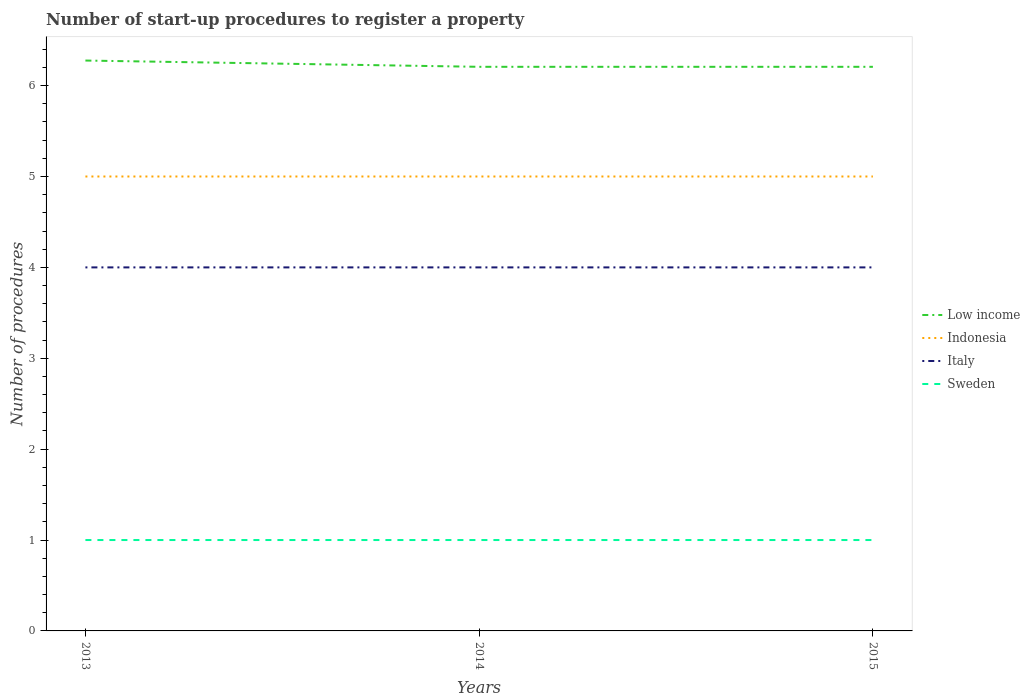How many different coloured lines are there?
Give a very brief answer. 4. Does the line corresponding to Italy intersect with the line corresponding to Indonesia?
Offer a terse response. No. Across all years, what is the maximum number of procedures required to register a property in Sweden?
Keep it short and to the point. 1. In which year was the number of procedures required to register a property in Low income maximum?
Offer a terse response. 2014. What is the total number of procedures required to register a property in Sweden in the graph?
Keep it short and to the point. 0. What is the difference between the highest and the second highest number of procedures required to register a property in Low income?
Make the answer very short. 0.07. What is the difference between the highest and the lowest number of procedures required to register a property in Indonesia?
Ensure brevity in your answer.  0. Is the number of procedures required to register a property in Sweden strictly greater than the number of procedures required to register a property in Indonesia over the years?
Your answer should be very brief. Yes. How many lines are there?
Provide a succinct answer. 4. How many years are there in the graph?
Your response must be concise. 3. Does the graph contain any zero values?
Give a very brief answer. No. Does the graph contain grids?
Offer a terse response. No. Where does the legend appear in the graph?
Your response must be concise. Center right. What is the title of the graph?
Give a very brief answer. Number of start-up procedures to register a property. What is the label or title of the X-axis?
Give a very brief answer. Years. What is the label or title of the Y-axis?
Ensure brevity in your answer.  Number of procedures. What is the Number of procedures of Low income in 2013?
Your response must be concise. 6.28. What is the Number of procedures in Indonesia in 2013?
Keep it short and to the point. 5. What is the Number of procedures in Sweden in 2013?
Provide a succinct answer. 1. What is the Number of procedures in Low income in 2014?
Make the answer very short. 6.21. What is the Number of procedures in Indonesia in 2014?
Keep it short and to the point. 5. What is the Number of procedures in Low income in 2015?
Your answer should be very brief. 6.21. What is the Number of procedures of Sweden in 2015?
Ensure brevity in your answer.  1. Across all years, what is the maximum Number of procedures in Low income?
Your answer should be very brief. 6.28. Across all years, what is the maximum Number of procedures of Indonesia?
Your answer should be very brief. 5. Across all years, what is the maximum Number of procedures in Italy?
Your response must be concise. 4. Across all years, what is the maximum Number of procedures in Sweden?
Provide a succinct answer. 1. Across all years, what is the minimum Number of procedures in Low income?
Your response must be concise. 6.21. What is the total Number of procedures in Low income in the graph?
Provide a short and direct response. 18.69. What is the total Number of procedures of Italy in the graph?
Keep it short and to the point. 12. What is the total Number of procedures in Sweden in the graph?
Your answer should be very brief. 3. What is the difference between the Number of procedures in Low income in 2013 and that in 2014?
Your answer should be very brief. 0.07. What is the difference between the Number of procedures in Italy in 2013 and that in 2014?
Offer a terse response. 0. What is the difference between the Number of procedures of Sweden in 2013 and that in 2014?
Provide a short and direct response. 0. What is the difference between the Number of procedures in Low income in 2013 and that in 2015?
Provide a short and direct response. 0.07. What is the difference between the Number of procedures in Indonesia in 2013 and that in 2015?
Offer a terse response. 0. What is the difference between the Number of procedures of Sweden in 2014 and that in 2015?
Provide a succinct answer. 0. What is the difference between the Number of procedures in Low income in 2013 and the Number of procedures in Indonesia in 2014?
Offer a terse response. 1.28. What is the difference between the Number of procedures of Low income in 2013 and the Number of procedures of Italy in 2014?
Your answer should be very brief. 2.28. What is the difference between the Number of procedures in Low income in 2013 and the Number of procedures in Sweden in 2014?
Provide a succinct answer. 5.28. What is the difference between the Number of procedures of Low income in 2013 and the Number of procedures of Indonesia in 2015?
Give a very brief answer. 1.28. What is the difference between the Number of procedures of Low income in 2013 and the Number of procedures of Italy in 2015?
Offer a terse response. 2.28. What is the difference between the Number of procedures of Low income in 2013 and the Number of procedures of Sweden in 2015?
Offer a very short reply. 5.28. What is the difference between the Number of procedures of Indonesia in 2013 and the Number of procedures of Italy in 2015?
Give a very brief answer. 1. What is the difference between the Number of procedures of Low income in 2014 and the Number of procedures of Indonesia in 2015?
Provide a succinct answer. 1.21. What is the difference between the Number of procedures in Low income in 2014 and the Number of procedures in Italy in 2015?
Your response must be concise. 2.21. What is the difference between the Number of procedures in Low income in 2014 and the Number of procedures in Sweden in 2015?
Offer a terse response. 5.21. What is the difference between the Number of procedures of Indonesia in 2014 and the Number of procedures of Italy in 2015?
Provide a short and direct response. 1. What is the difference between the Number of procedures in Italy in 2014 and the Number of procedures in Sweden in 2015?
Provide a succinct answer. 3. What is the average Number of procedures of Low income per year?
Your response must be concise. 6.23. What is the average Number of procedures of Italy per year?
Provide a short and direct response. 4. What is the average Number of procedures of Sweden per year?
Give a very brief answer. 1. In the year 2013, what is the difference between the Number of procedures of Low income and Number of procedures of Indonesia?
Your answer should be very brief. 1.28. In the year 2013, what is the difference between the Number of procedures in Low income and Number of procedures in Italy?
Provide a short and direct response. 2.28. In the year 2013, what is the difference between the Number of procedures of Low income and Number of procedures of Sweden?
Your answer should be very brief. 5.28. In the year 2013, what is the difference between the Number of procedures of Indonesia and Number of procedures of Sweden?
Make the answer very short. 4. In the year 2013, what is the difference between the Number of procedures in Italy and Number of procedures in Sweden?
Provide a short and direct response. 3. In the year 2014, what is the difference between the Number of procedures of Low income and Number of procedures of Indonesia?
Your response must be concise. 1.21. In the year 2014, what is the difference between the Number of procedures of Low income and Number of procedures of Italy?
Give a very brief answer. 2.21. In the year 2014, what is the difference between the Number of procedures in Low income and Number of procedures in Sweden?
Provide a succinct answer. 5.21. In the year 2014, what is the difference between the Number of procedures of Indonesia and Number of procedures of Italy?
Offer a terse response. 1. In the year 2014, what is the difference between the Number of procedures of Italy and Number of procedures of Sweden?
Give a very brief answer. 3. In the year 2015, what is the difference between the Number of procedures of Low income and Number of procedures of Indonesia?
Make the answer very short. 1.21. In the year 2015, what is the difference between the Number of procedures in Low income and Number of procedures in Italy?
Ensure brevity in your answer.  2.21. In the year 2015, what is the difference between the Number of procedures of Low income and Number of procedures of Sweden?
Your answer should be compact. 5.21. In the year 2015, what is the difference between the Number of procedures of Indonesia and Number of procedures of Sweden?
Your response must be concise. 4. What is the ratio of the Number of procedures of Low income in 2013 to that in 2014?
Your answer should be very brief. 1.01. What is the ratio of the Number of procedures in Indonesia in 2013 to that in 2014?
Make the answer very short. 1. What is the ratio of the Number of procedures in Low income in 2013 to that in 2015?
Ensure brevity in your answer.  1.01. What is the ratio of the Number of procedures of Italy in 2013 to that in 2015?
Keep it short and to the point. 1. What is the ratio of the Number of procedures of Indonesia in 2014 to that in 2015?
Provide a succinct answer. 1. What is the ratio of the Number of procedures of Italy in 2014 to that in 2015?
Provide a short and direct response. 1. What is the ratio of the Number of procedures of Sweden in 2014 to that in 2015?
Provide a succinct answer. 1. What is the difference between the highest and the second highest Number of procedures of Low income?
Offer a very short reply. 0.07. What is the difference between the highest and the second highest Number of procedures of Indonesia?
Give a very brief answer. 0. What is the difference between the highest and the second highest Number of procedures in Italy?
Your answer should be compact. 0. What is the difference between the highest and the second highest Number of procedures of Sweden?
Make the answer very short. 0. What is the difference between the highest and the lowest Number of procedures in Low income?
Ensure brevity in your answer.  0.07. What is the difference between the highest and the lowest Number of procedures of Indonesia?
Give a very brief answer. 0. What is the difference between the highest and the lowest Number of procedures in Sweden?
Keep it short and to the point. 0. 